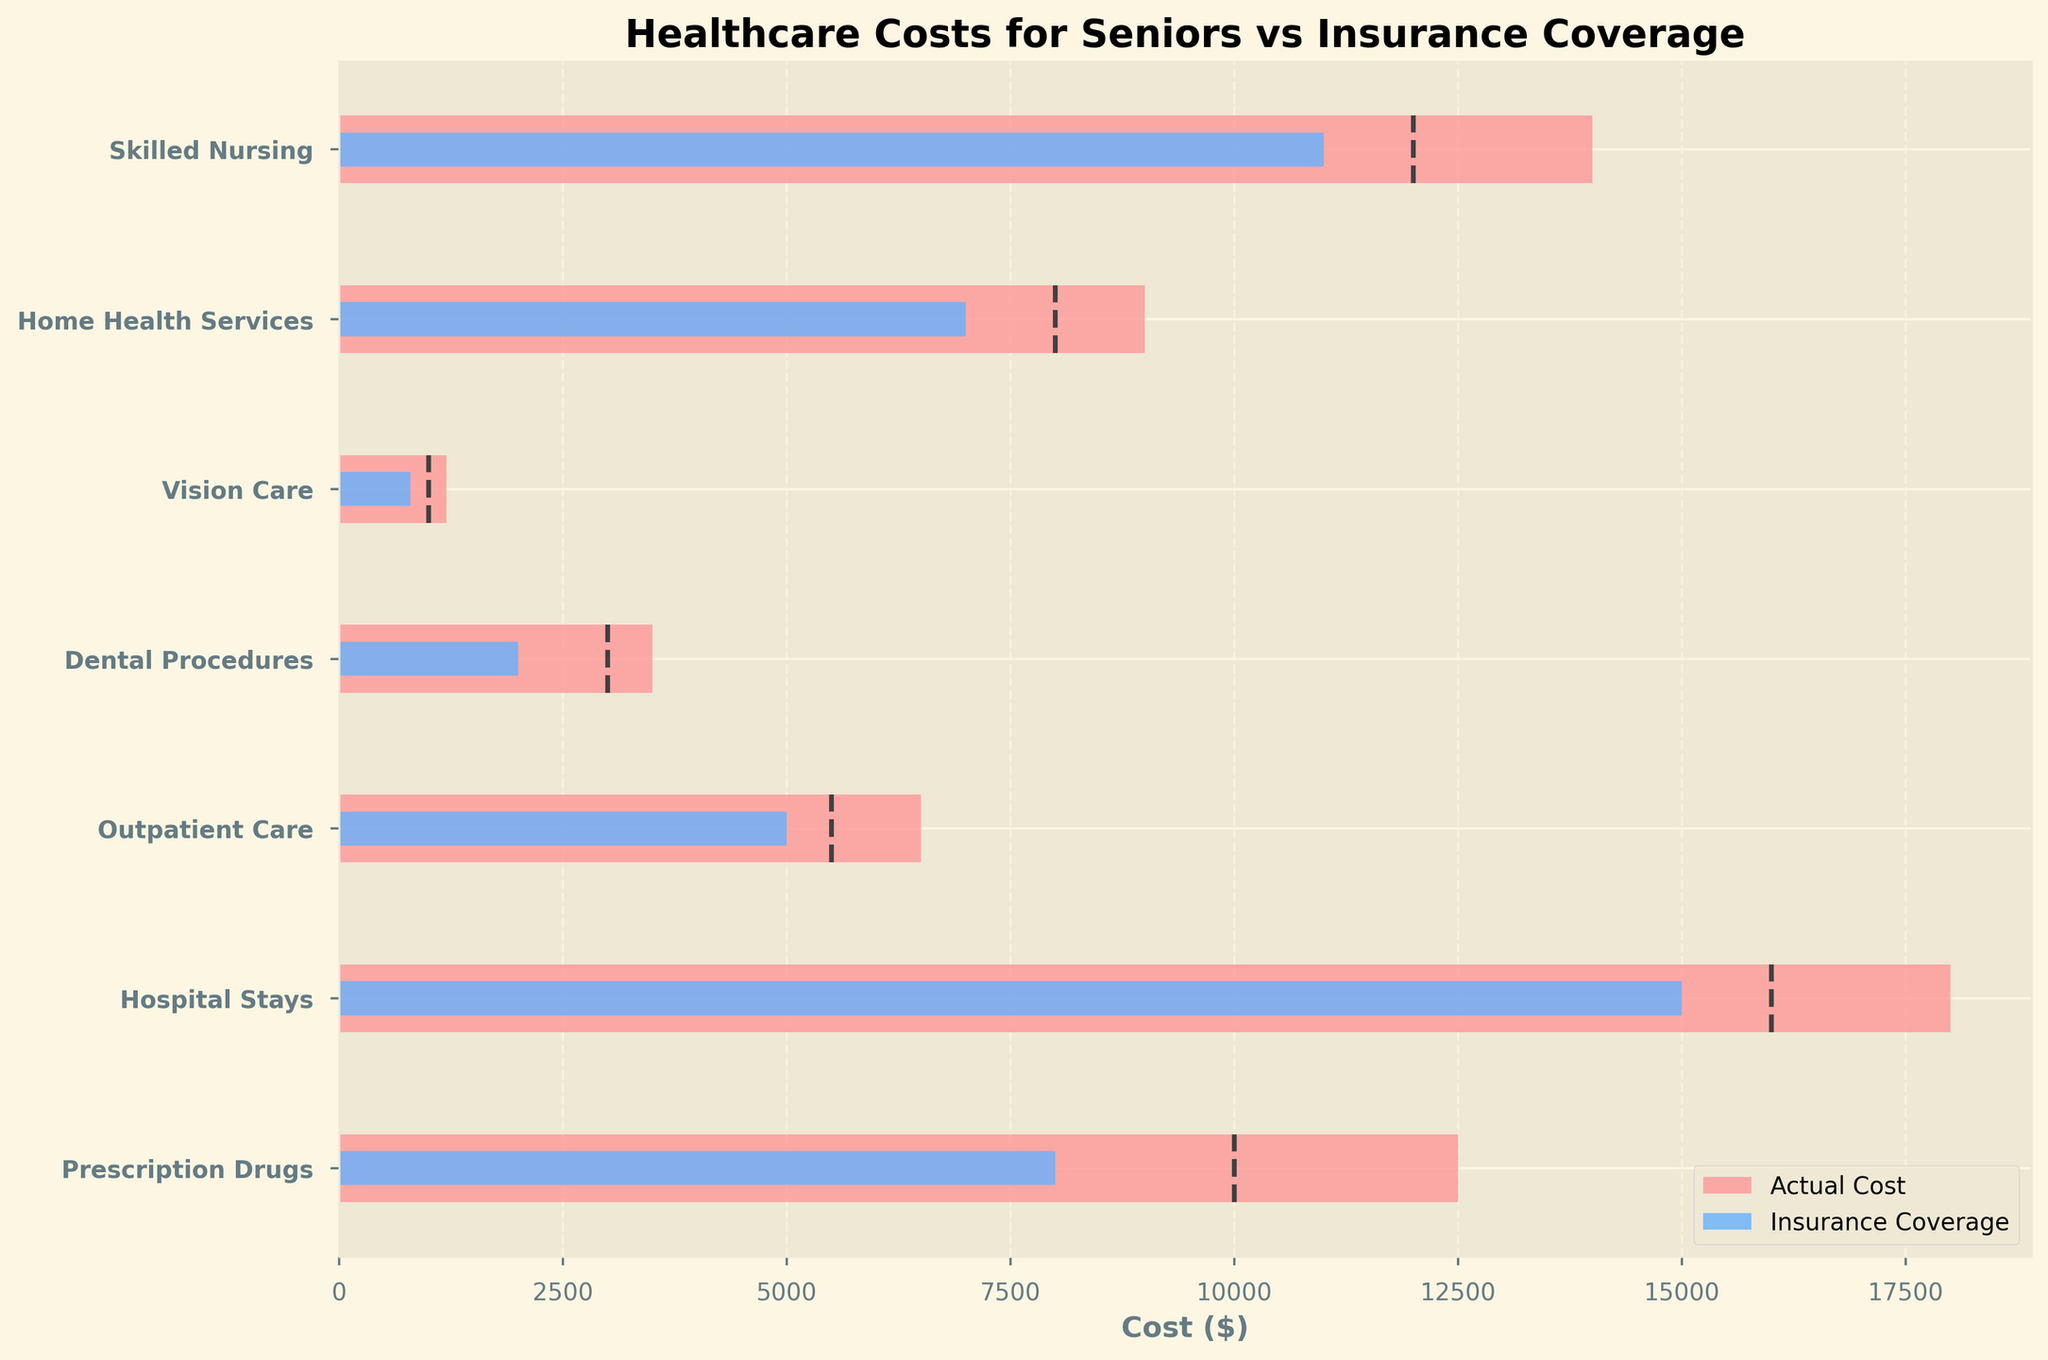What's the title of the chart? The title of the chart is positioned prominently at the top and reads 'Healthcare Costs for Seniors vs Insurance Coverage'
Answer: Healthcare Costs for Seniors vs Insurance Coverage How many categories are compared in the chart? There are horizontal bars in the chart, each corresponding to a category related to healthcare costs. Visual inspection reveals there are 7 such bars
Answer: 7 Which category has the highest actual cost? By comparing the length of the actual cost bars, 'Hospital Stays' has the longest bar, indicating the highest actual cost
Answer: Hospital Stays Which category has the smallest actual cost? The category with the shortest bar for actual costs is 'Vision Care,' signifying it has the smallest actual cost
Answer: Vision Care What's the difference between actual cost and insurance coverage for Prescription Drugs? The actual cost for 'Prescription Drugs' is $12,500 and insurance coverage is $8,000. The difference is calculated by subtracting the insurance coverage from the actual cost: 12500 - 8000
Answer: 4500 Which category has the closest actual cost to its target cost? By visually inspecting the bars and the dashed lines representing target costs, 'Skilled Nursing' has an actual cost of $14,000 and a target cost of $12,000, showing the smallest difference compared to other categories
Answer: Skilled Nursing Is the insurance coverage for Home Health Services above or below the target cost? The dashed line indicating the target cost of $8,000 is above the blue bar representing the insurance coverage of $7,000 for 'Home Health Services'
Answer: Below How much more is the actual cost than the insurance coverage for Skilled Nursing? The actual cost for 'Skilled Nursing' is $14,000 and the insurance coverage is $11,000. The difference is calculated by subtracting the insurance coverage from the actual cost: 14000 - 11000
Answer: 3000 Which category has insurance coverage exactly equal to its target cost? By comparing the blue bars (insurance coverage) and the dashed lines (target costs), no category has insurance coverage exactly equal to its target cost
Answer: None Which three categories have the largest gaps between actual costs and insurance coverage? Calculating the gaps: Prescription Drugs ($4,500), Hospital Stays ($3,000), Outpatient Care ($1,500). 'Vision Care,' 'Dental Procedures,' 'Home Health Services,' and 'Skilled Nursing' have smaller gaps making the top three: Prescription Drugs, Hospital Stays, and Outpatient Care
Answer: Prescription Drugs, Hospital Stays, Outpatient Care 